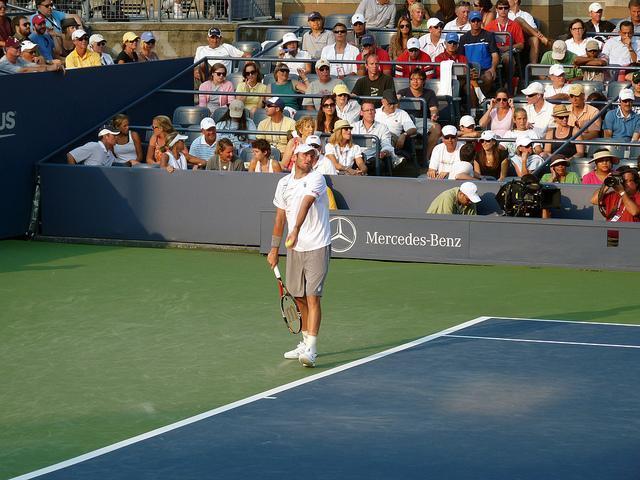How many people are in the photo?
Give a very brief answer. 2. How many chairs are in the photo?
Give a very brief answer. 1. How many people have dress ties on?
Give a very brief answer. 0. 